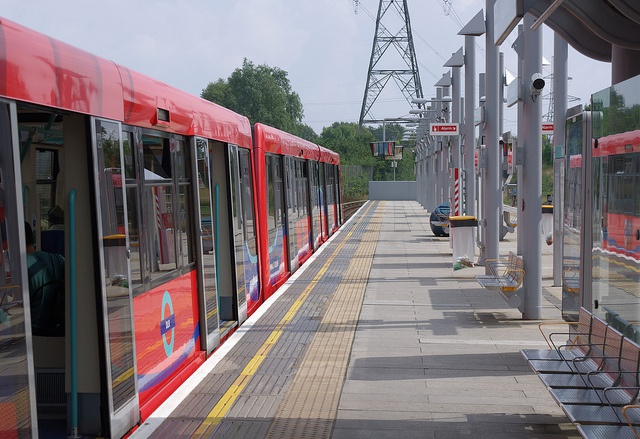Describe the objects in this image and their specific colors. I can see train in lavender, black, gray, darkgray, and lightpink tones, bench in lavender, gray, black, and darkgray tones, train in lavender, gray, brown, and black tones, people in lavender, black, teal, and gray tones, and chair in lavender, gray, black, and darkgray tones in this image. 